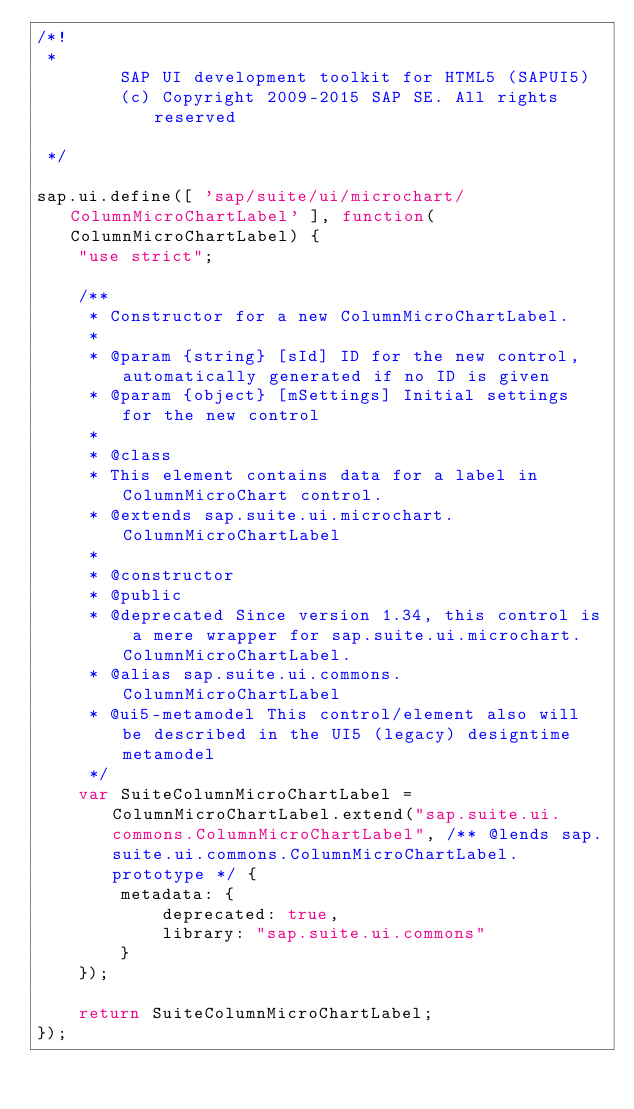Convert code to text. <code><loc_0><loc_0><loc_500><loc_500><_JavaScript_>/*!
 * 
		SAP UI development toolkit for HTML5 (SAPUI5)
		(c) Copyright 2009-2015 SAP SE. All rights reserved
	
 */

sap.ui.define([ 'sap/suite/ui/microchart/ColumnMicroChartLabel' ], function(ColumnMicroChartLabel) {
	"use strict";

	/**
	 * Constructor for a new ColumnMicroChartLabel.
	 *
	 * @param {string} [sId] ID for the new control, automatically generated if no ID is given
	 * @param {object} [mSettings] Initial settings for the new control
	 *
	 * @class
	 * This element contains data for a label in ColumnMicroChart control.
	 * @extends sap.suite.ui.microchart.ColumnMicroChartLabel
	 *
	 * @constructor
	 * @public
	 * @deprecated Since version 1.34, this control is a mere wrapper for sap.suite.ui.microchart.ColumnMicroChartLabel.
	 * @alias sap.suite.ui.commons.ColumnMicroChartLabel
	 * @ui5-metamodel This control/element also will be described in the UI5 (legacy) designtime metamodel
	 */
	var SuiteColumnMicroChartLabel = ColumnMicroChartLabel.extend("sap.suite.ui.commons.ColumnMicroChartLabel", /** @lends sap.suite.ui.commons.ColumnMicroChartLabel.prototype */ {
		metadata: {
			deprecated: true,
			library: "sap.suite.ui.commons"
		}
	});

	return SuiteColumnMicroChartLabel;
});
</code> 